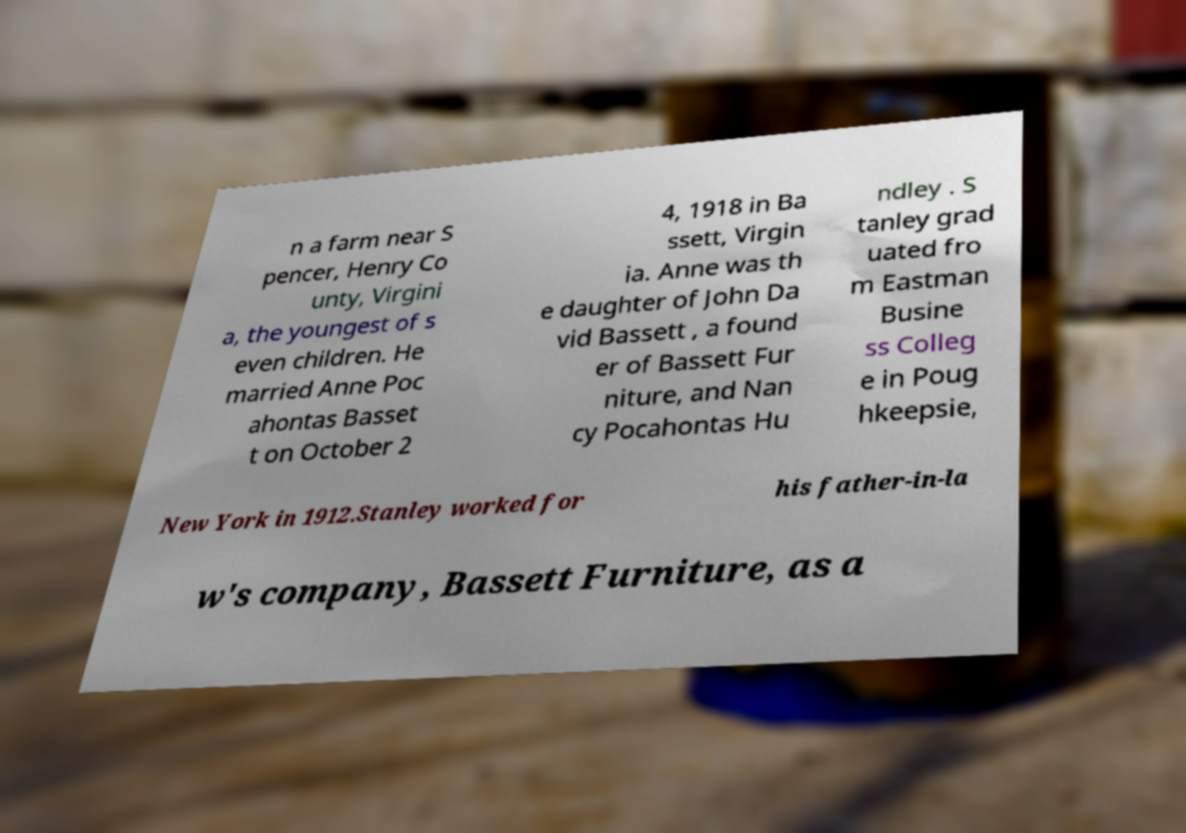There's text embedded in this image that I need extracted. Can you transcribe it verbatim? n a farm near S pencer, Henry Co unty, Virgini a, the youngest of s even children. He married Anne Poc ahontas Basset t on October 2 4, 1918 in Ba ssett, Virgin ia. Anne was th e daughter of John Da vid Bassett , a found er of Bassett Fur niture, and Nan cy Pocahontas Hu ndley . S tanley grad uated fro m Eastman Busine ss Colleg e in Poug hkeepsie, New York in 1912.Stanley worked for his father-in-la w's company, Bassett Furniture, as a 